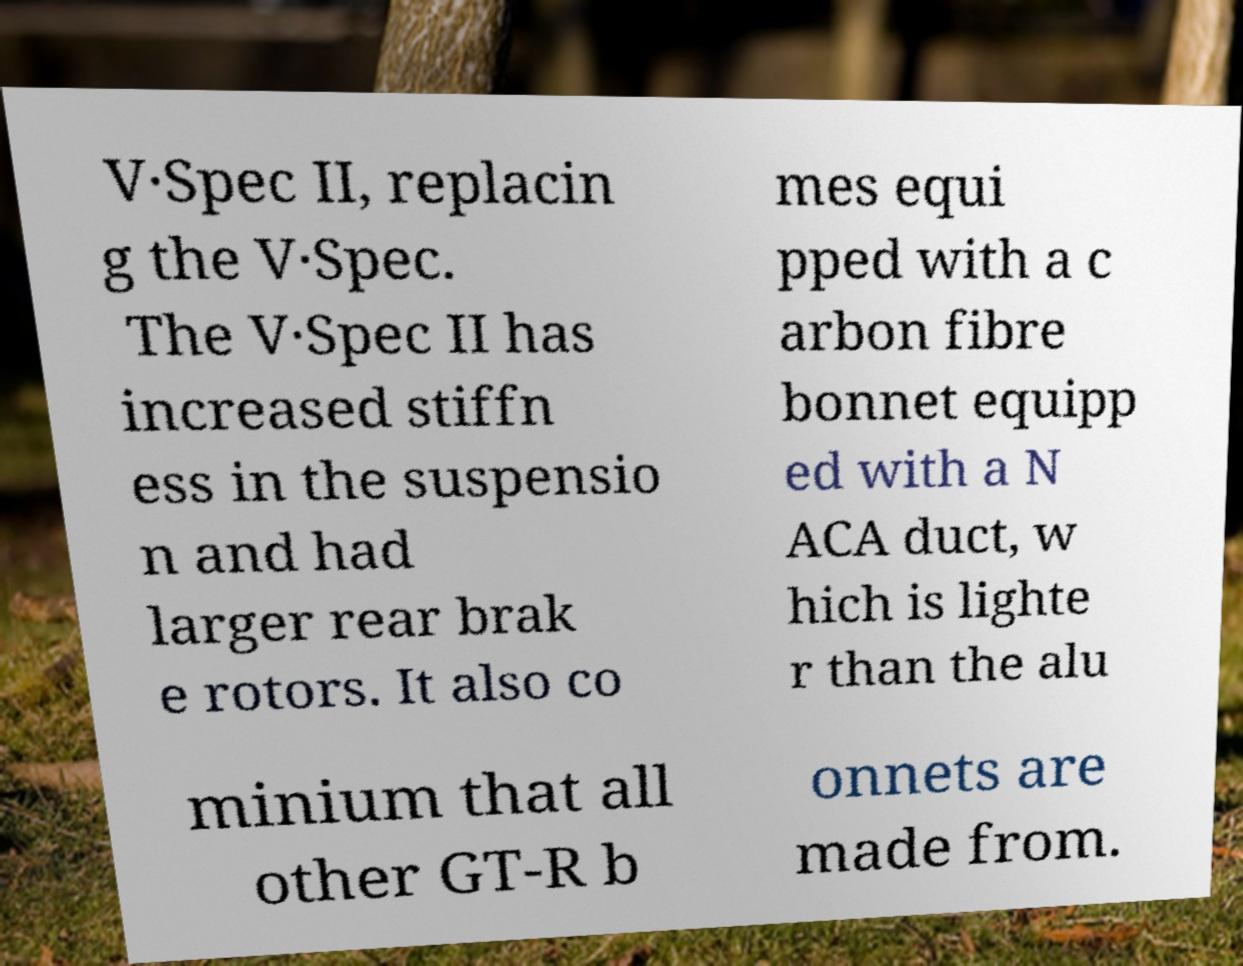Could you extract and type out the text from this image? V·Spec II, replacin g the V·Spec. The V·Spec II has increased stiffn ess in the suspensio n and had larger rear brak e rotors. It also co mes equi pped with a c arbon fibre bonnet equipp ed with a N ACA duct, w hich is lighte r than the alu minium that all other GT-R b onnets are made from. 